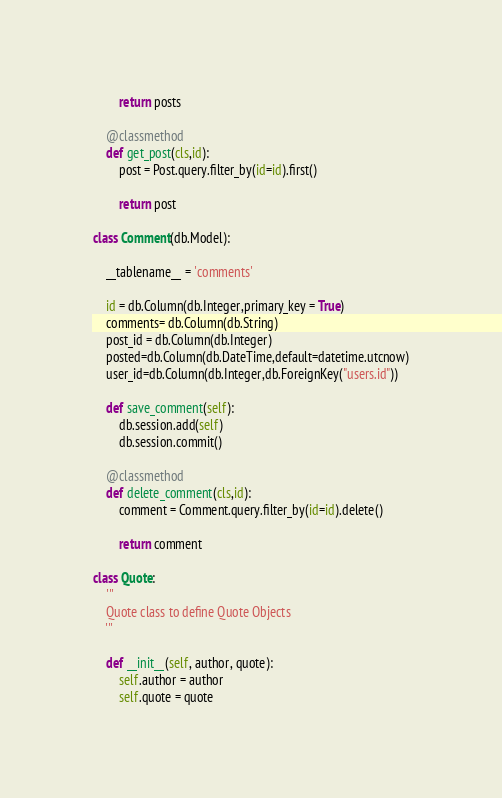Convert code to text. <code><loc_0><loc_0><loc_500><loc_500><_Python_>        return posts

    @classmethod
    def get_post(cls,id):
        post = Post.query.filter_by(id=id).first()

        return post 
    
class Comment(db.Model):
    
    __tablename__ = 'comments'

    id = db.Column(db.Integer,primary_key = True)
    comments= db.Column(db.String)
    post_id = db.Column(db.Integer)
    posted=db.Column(db.DateTime,default=datetime.utcnow)
    user_id=db.Column(db.Integer,db.ForeignKey("users.id"))
    
    def save_comment(self):
        db.session.add(self)
        db.session.commit()
        
    @classmethod
    def delete_comment(cls,id):
        comment = Comment.query.filter_by(id=id).delete()

        return comment 

class Quote:
    '''
    Quote class to define Quote Objects
    '''

    def __init__(self, author, quote):
        self.author = author
        self.quote = quote</code> 